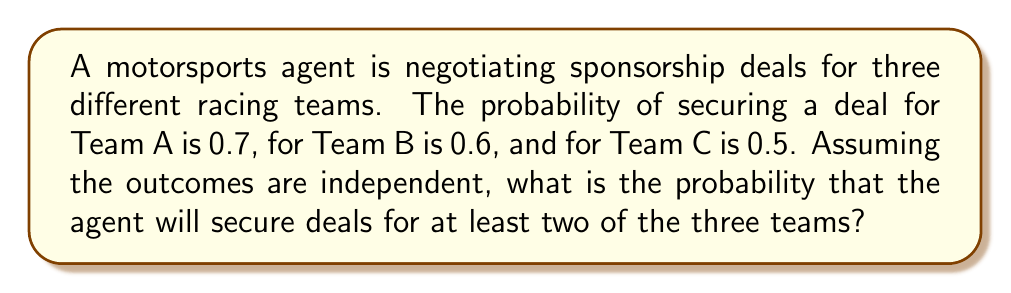Provide a solution to this math problem. Let's approach this step-by-step:

1) First, we need to identify the possible scenarios where at least two deals are secured:
   - All three teams get deals
   - Only teams A and B get deals
   - Only teams A and C get deals
   - Only teams B and C get deals

2) Let's calculate the probability of each scenario:

   a) All three teams get deals:
      $P(\text{A and B and C}) = 0.7 \times 0.6 \times 0.5 = 0.21$

   b) Only A and B get deals:
      $P(\text{A and B and not C}) = 0.7 \times 0.6 \times (1-0.5) = 0.21$

   c) Only A and C get deals:
      $P(\text{A and C and not B}) = 0.7 \times (1-0.6) \times 0.5 = 0.14$

   d) Only B and C get deals:
      $P(\text{B and C and not A}) = (1-0.7) \times 0.6 \times 0.5 = 0.09$

3) The probability of at least two deals is the sum of these probabilities:

   $P(\text{at least two deals}) = 0.21 + 0.21 + 0.14 + 0.09 = 0.65$

4) We can verify this result using the complement method:

   $P(\text{at least two deals}) = 1 - P(\text{one or no deals})$

   $P(\text{one or no deals}) = P(\text{no deals}) + P(\text{only A}) + P(\text{only B}) + P(\text{only C})$

   $= (0.3 \times 0.4 \times 0.5) + (0.7 \times 0.4 \times 0.5) + (0.3 \times 0.6 \times 0.5) + (0.3 \times 0.4 \times 0.5)$

   $= 0.06 + 0.14 + 0.09 + 0.06 = 0.35$

   Thus, $P(\text{at least two deals}) = 1 - 0.35 = 0.65$

This confirms our initial calculation.
Answer: The probability of securing deals for at least two of the three teams is 0.65 or 65%. 